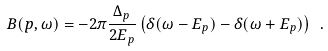Convert formula to latex. <formula><loc_0><loc_0><loc_500><loc_500>B ( p , \omega ) = - 2 \pi \frac { \Delta _ { p } } { 2 E _ { p } } \left ( \delta ( \omega - E _ { p } ) - \delta ( \omega + E _ { p } ) \right ) \ .</formula> 